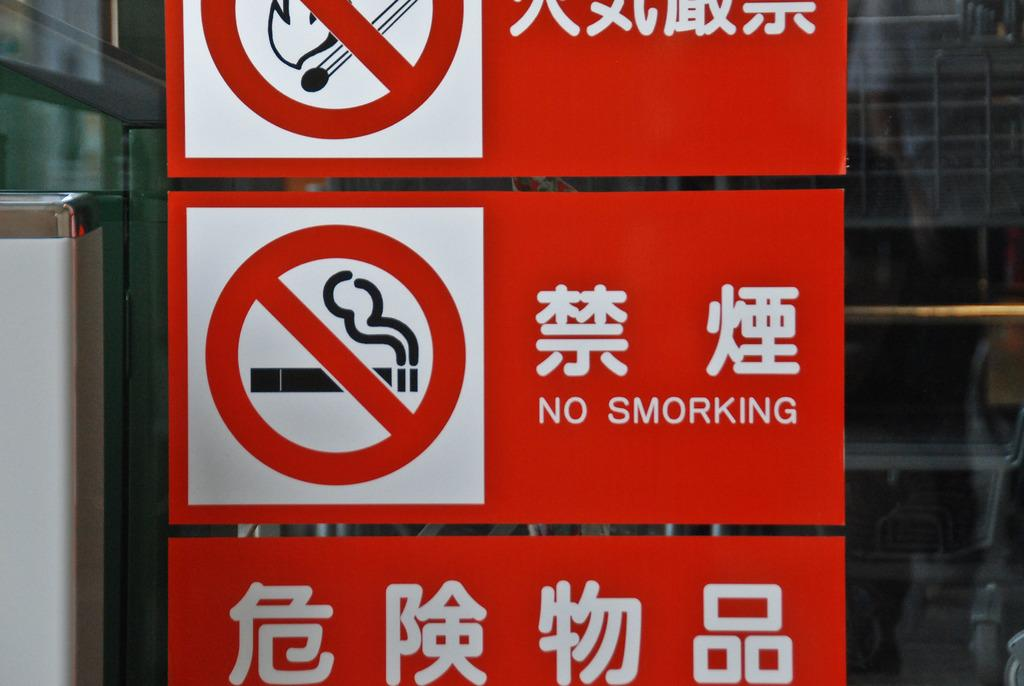What type of signage is present in the image? There are red color caution boards in the image. What information is provided on the caution boards? The caution boards have text on them. What else can be seen on the glass doors in the image? There are images pasted on the glass doors. What type of cord is hanging from the ceiling in the image? There is no cord hanging from the ceiling in the image. Can you tell me how many stomachs are visible in the image? There are no stomachs visible in the image. 